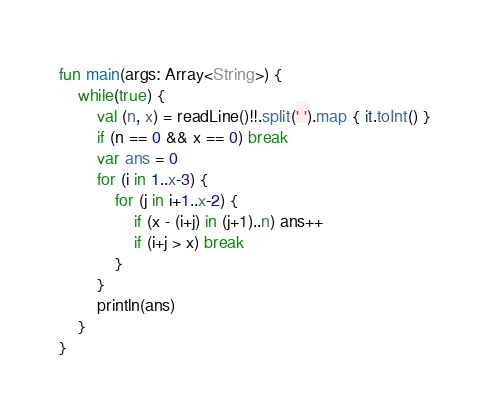<code> <loc_0><loc_0><loc_500><loc_500><_Kotlin_>fun main(args: Array<String>) {
    while(true) {
        val (n, x) = readLine()!!.split(' ').map { it.toInt() }
        if (n == 0 && x == 0) break
        var ans = 0
        for (i in 1..x-3) {
            for (j in i+1..x-2) {
                if (x - (i+j) in (j+1)..n) ans++
                if (i+j > x) break
            }
        }
        println(ans)
    }
}

</code> 